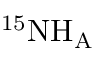Convert formula to latex. <formula><loc_0><loc_0><loc_500><loc_500>^ { 1 5 } N H _ { A }</formula> 